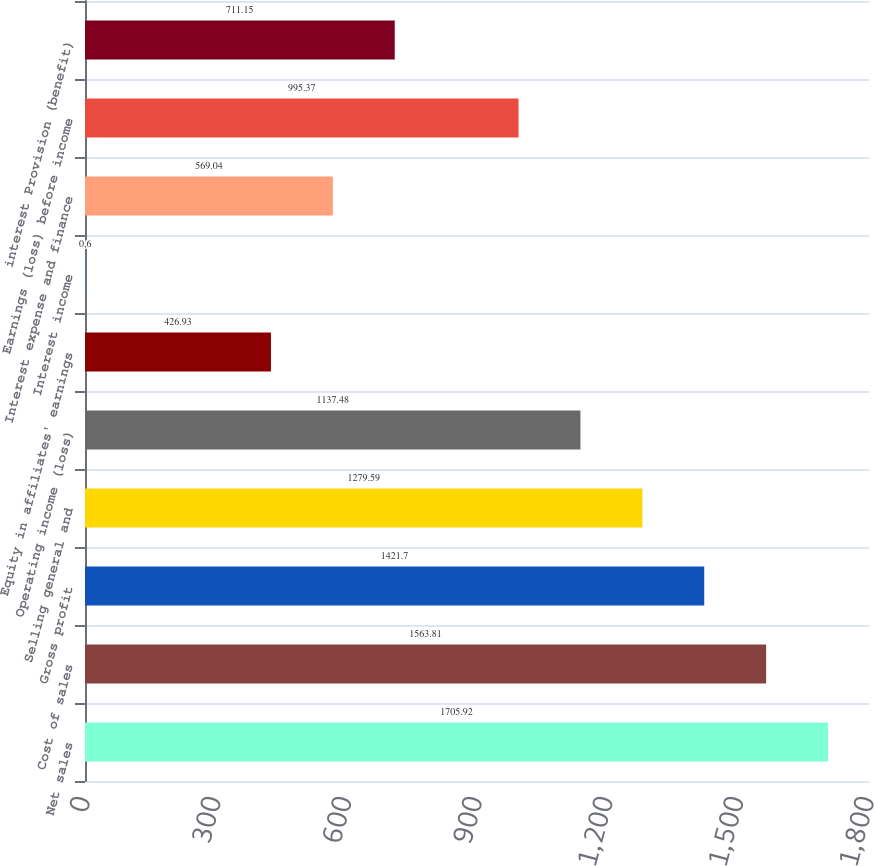<chart> <loc_0><loc_0><loc_500><loc_500><bar_chart><fcel>Net sales<fcel>Cost of sales<fcel>Gross profit<fcel>Selling general and<fcel>Operating income (loss)<fcel>Equity in affiliates' earnings<fcel>Interest income<fcel>Interest expense and finance<fcel>Earnings (loss) before income<fcel>interest Provision (benefit)<nl><fcel>1705.92<fcel>1563.81<fcel>1421.7<fcel>1279.59<fcel>1137.48<fcel>426.93<fcel>0.6<fcel>569.04<fcel>995.37<fcel>711.15<nl></chart> 